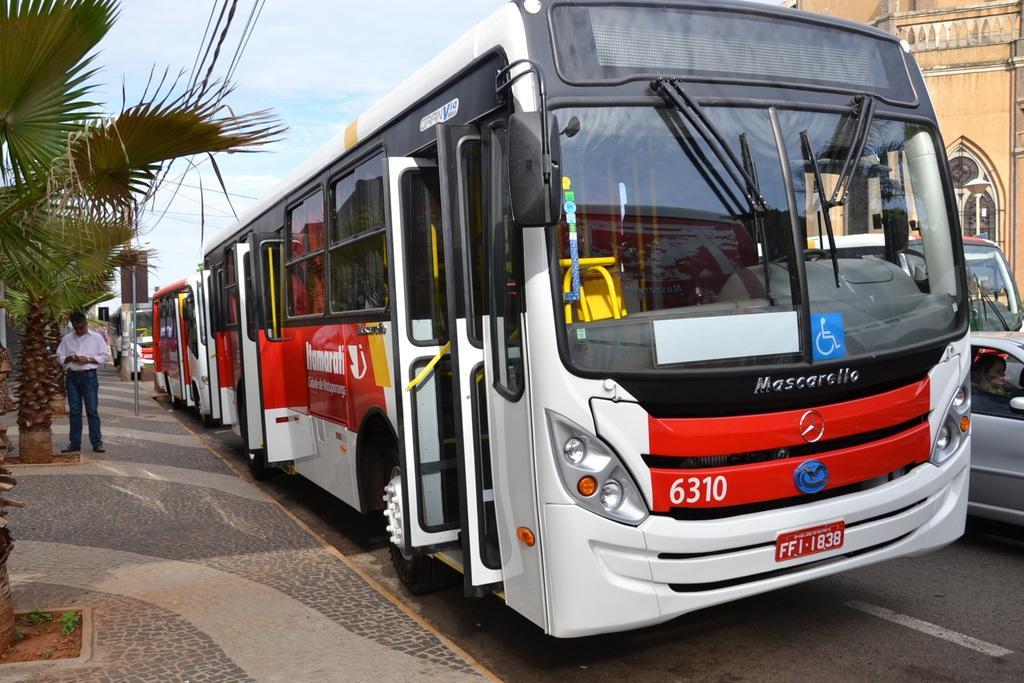Could you give a brief overview of what you see in this image? As we can see in the image there is a building, cars, buses, sky, trees and a person standing on the left side. 